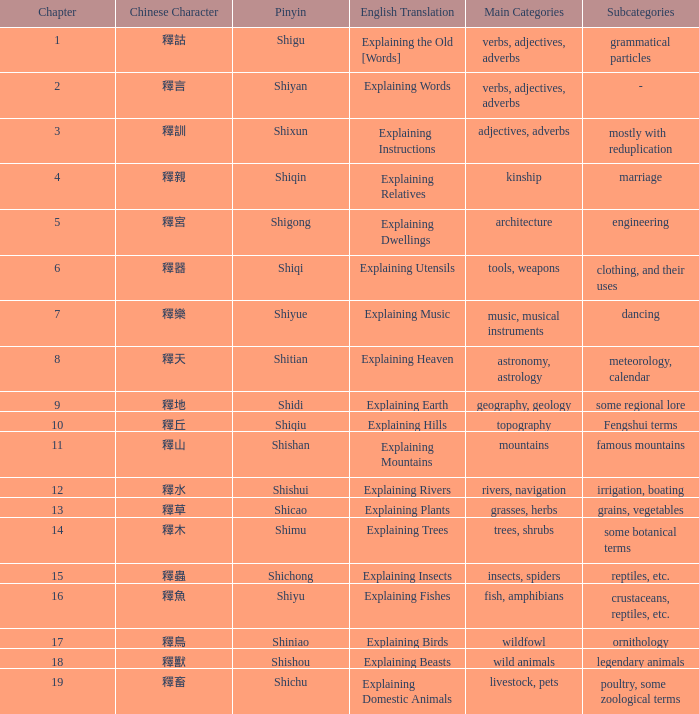Name the subject of shiyan Verbs, adjectives, adverbs. 